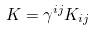Convert formula to latex. <formula><loc_0><loc_0><loc_500><loc_500>K = \gamma ^ { i j } K _ { i j }</formula> 